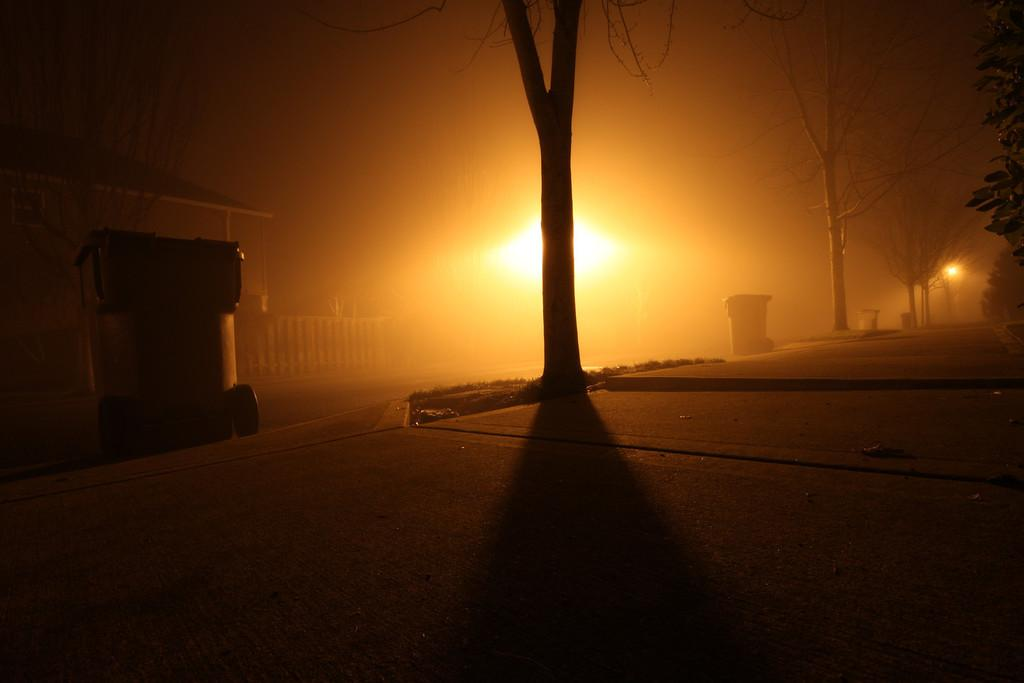What color is the light visible in the image? There is a yellow color light in the image. What objects can be seen on the footpath in the image? There are dustbins on the footpath in the image. What type of vegetation is present in the image? There are trees in the image. What type of channel can be seen running through the trees in the image? There is no channel visible in the image; it only features a yellow light, dustbins on the footpath, and trees. How much salt is present on the dustbins in the image? There is no salt present on the dustbins in the image. 